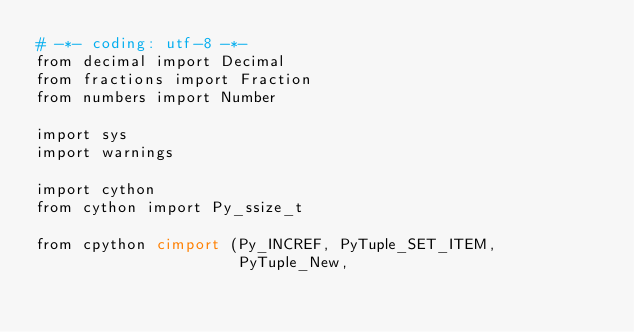Convert code to text. <code><loc_0><loc_0><loc_500><loc_500><_Cython_># -*- coding: utf-8 -*-
from decimal import Decimal
from fractions import Fraction
from numbers import Number

import sys
import warnings

import cython
from cython import Py_ssize_t

from cpython cimport (Py_INCREF, PyTuple_SET_ITEM,
                      PyTuple_New,</code> 